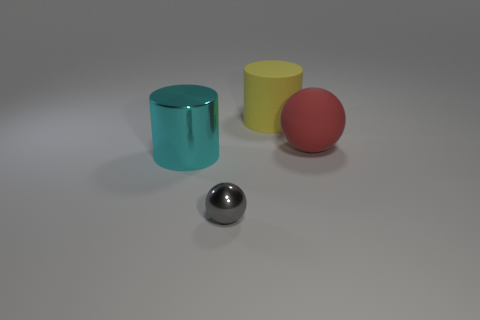There is a large yellow matte cylinder; are there any matte balls to the left of it? Indeed there are no matte balls to the left of the large yellow cylinder. To the left, there's a shiny metal sphere. The red ball is matte, but it's positioned on the right side of the yellow cylinder. 